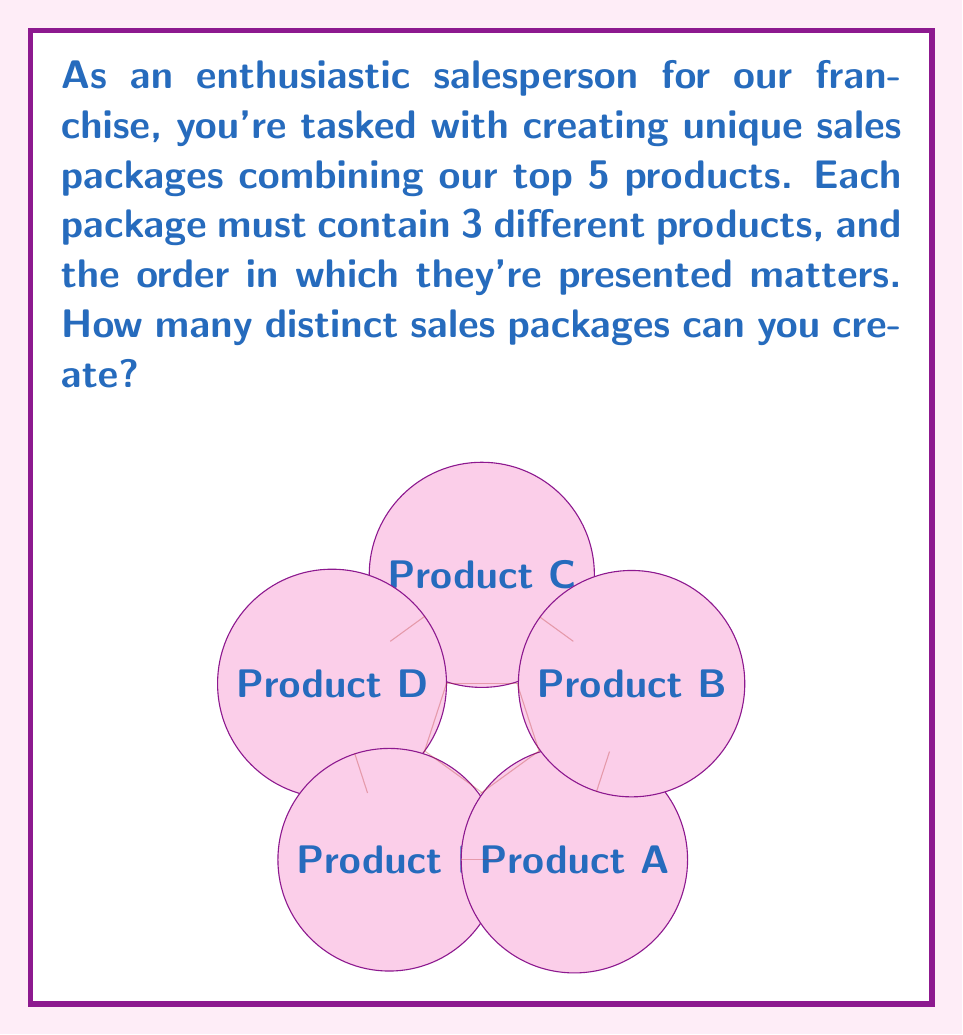Help me with this question. To solve this problem, we need to use the concept of permutations. Here's a step-by-step explanation:

1) We have 5 products in total, and we need to choose 3 of them for each package.

2) The order matters, which means we're dealing with permutations, not combinations.

3) This scenario is described by the permutation formula:
   $$P(n,r) = \frac{n!}{(n-r)!}$$
   where $n$ is the total number of items to choose from, and $r$ is the number of items being chosen.

4) In our case, $n = 5$ (total products) and $r = 3$ (products per package).

5) Plugging these values into the formula:
   $$P(5,3) = \frac{5!}{(5-3)!} = \frac{5!}{2!}$$

6) Expand this:
   $$\frac{5 \times 4 \times 3 \times 2!}{2!}$$

7) The $2!$ cancels out:
   $$5 \times 4 \times 3 = 60$$

Therefore, you can create 60 distinct sales packages.
Answer: 60 